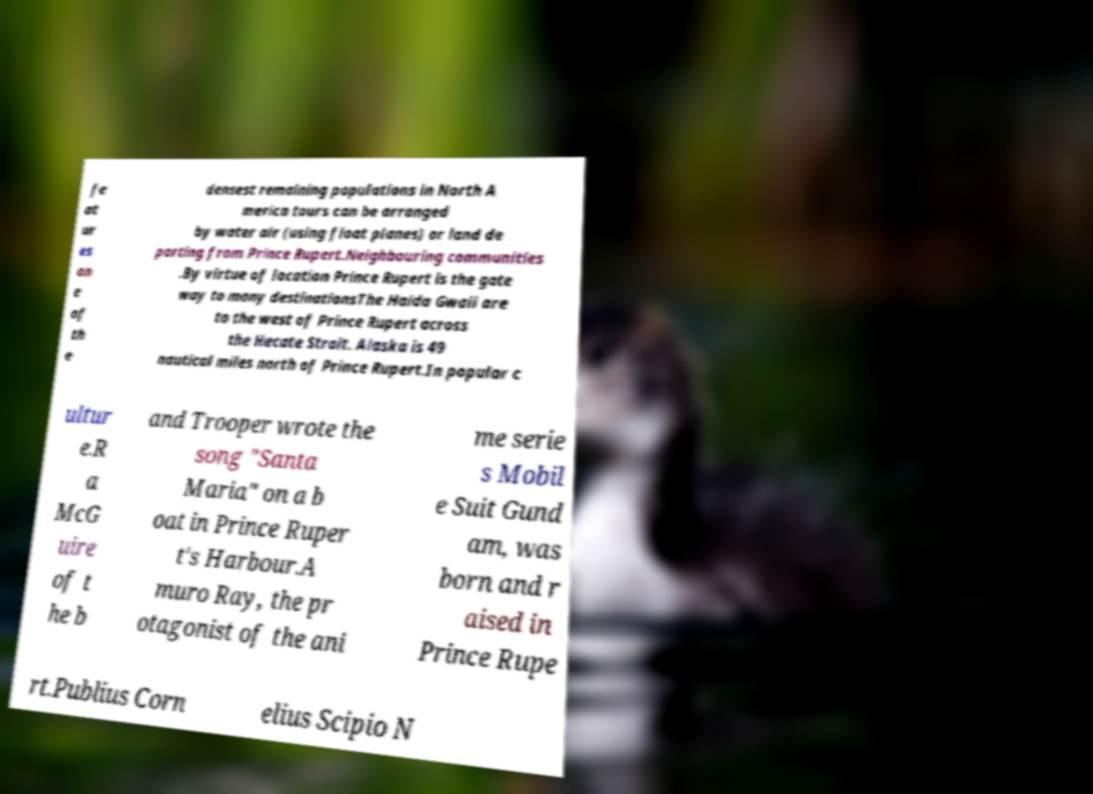Could you extract and type out the text from this image? fe at ur es on e of th e densest remaining populations in North A merica tours can be arranged by water air (using float planes) or land de parting from Prince Rupert.Neighbouring communities .By virtue of location Prince Rupert is the gate way to many destinationsThe Haida Gwaii are to the west of Prince Rupert across the Hecate Strait. Alaska is 49 nautical miles north of Prince Rupert.In popular c ultur e.R a McG uire of t he b and Trooper wrote the song "Santa Maria" on a b oat in Prince Ruper t's Harbour.A muro Ray, the pr otagonist of the ani me serie s Mobil e Suit Gund am, was born and r aised in Prince Rupe rt.Publius Corn elius Scipio N 